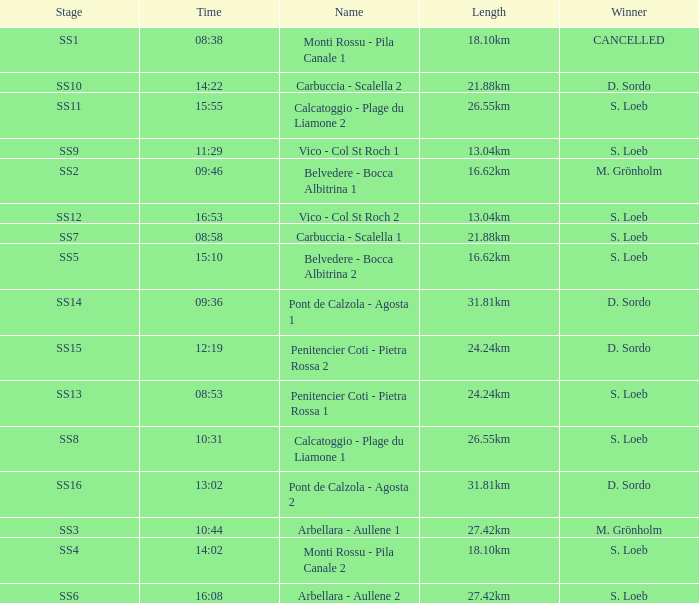What is the Name of the stage with S. Loeb as the Winner with a Length of 13.04km and a Stage of SS12? Vico - Col St Roch 2. 